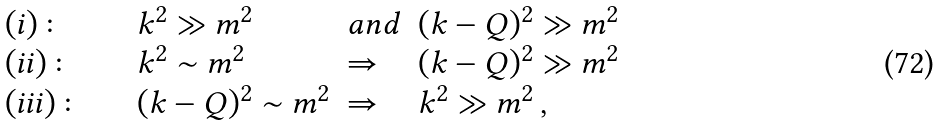Convert formula to latex. <formula><loc_0><loc_0><loc_500><loc_500>\begin{array} { l l l l } { ( i ) \colon \quad } & { { k ^ { 2 } \gg m ^ { 2 } \quad } } & { a n d } & { { ( k - Q ) ^ { 2 } \gg m ^ { 2 } } } \\ { ( i i ) \colon \quad } & { { k ^ { 2 } \sim m ^ { 2 } } } & { \Rightarrow } & { { ( k - Q ) ^ { 2 } \gg m ^ { 2 } } } \\ { ( i i i ) \colon \quad } & { { ( k - Q ) ^ { 2 } \sim m ^ { 2 } } } & { \Rightarrow } & { { k ^ { 2 } \gg m ^ { 2 } \, , } } \end{array}</formula> 